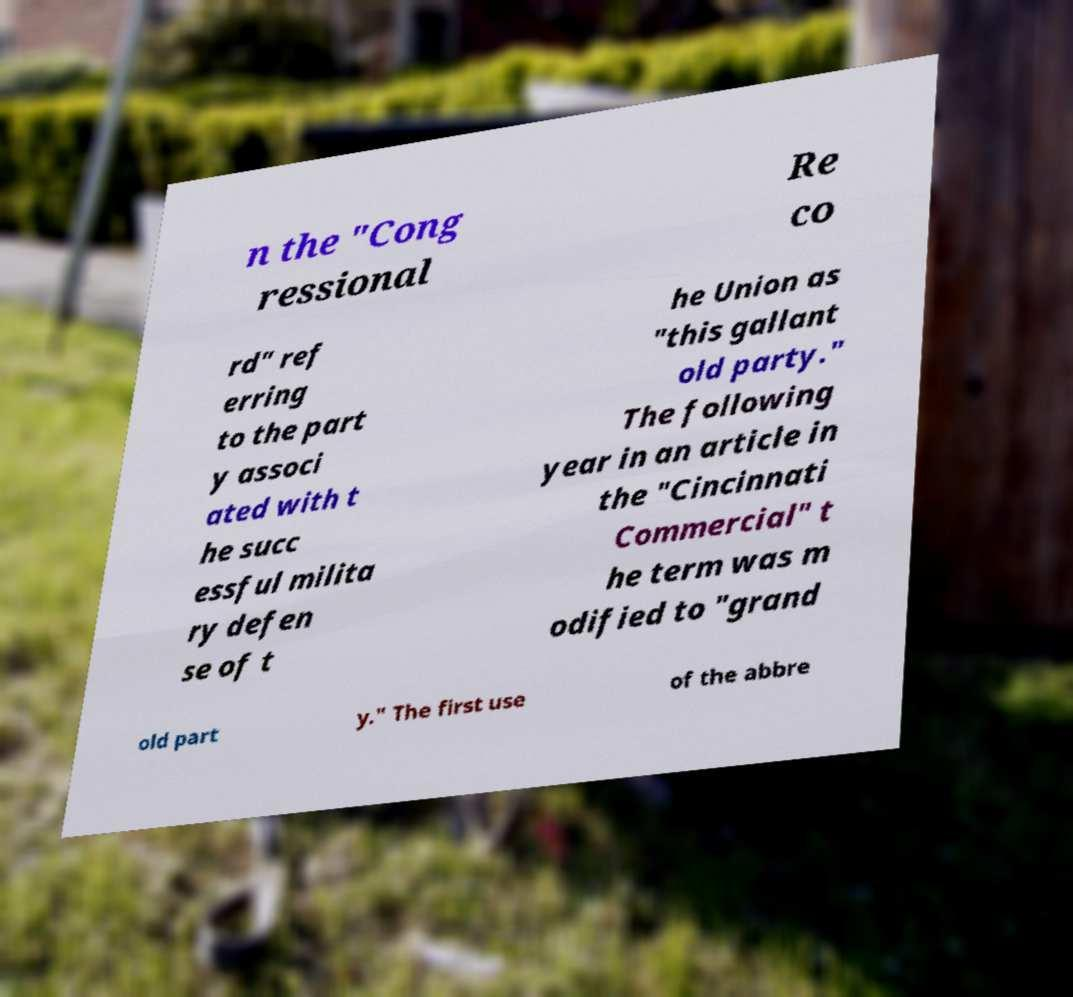I need the written content from this picture converted into text. Can you do that? n the "Cong ressional Re co rd" ref erring to the part y associ ated with t he succ essful milita ry defen se of t he Union as "this gallant old party." The following year in an article in the "Cincinnati Commercial" t he term was m odified to "grand old part y." The first use of the abbre 